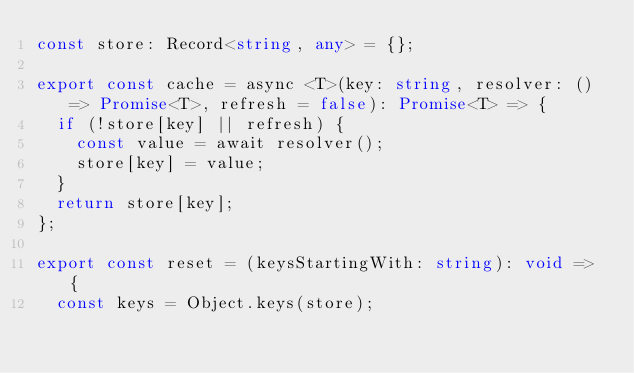Convert code to text. <code><loc_0><loc_0><loc_500><loc_500><_TypeScript_>const store: Record<string, any> = {};

export const cache = async <T>(key: string, resolver: () => Promise<T>, refresh = false): Promise<T> => {
  if (!store[key] || refresh) {
    const value = await resolver();
    store[key] = value;
  }
  return store[key];
};

export const reset = (keysStartingWith: string): void => {
  const keys = Object.keys(store);
</code> 